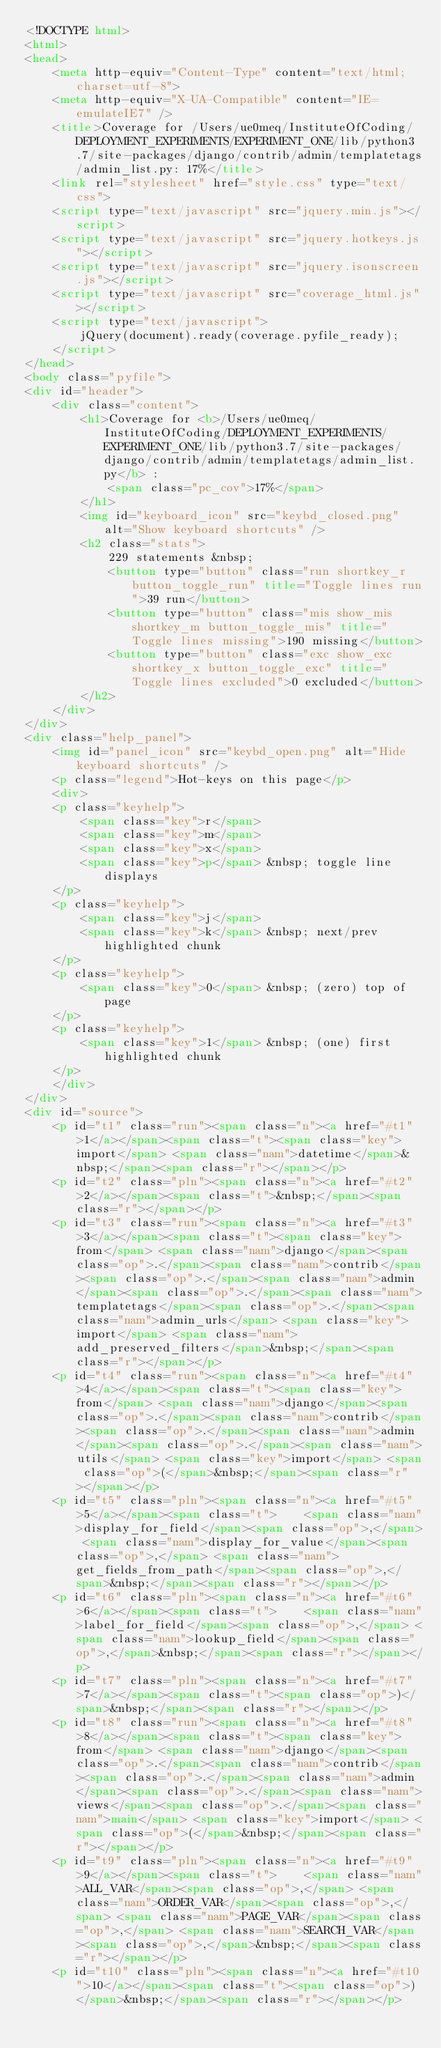Convert code to text. <code><loc_0><loc_0><loc_500><loc_500><_HTML_><!DOCTYPE html>
<html>
<head>
    <meta http-equiv="Content-Type" content="text/html; charset=utf-8">
    <meta http-equiv="X-UA-Compatible" content="IE=emulateIE7" />
    <title>Coverage for /Users/ue0meq/InstituteOfCoding/DEPLOYMENT_EXPERIMENTS/EXPERIMENT_ONE/lib/python3.7/site-packages/django/contrib/admin/templatetags/admin_list.py: 17%</title>
    <link rel="stylesheet" href="style.css" type="text/css">
    <script type="text/javascript" src="jquery.min.js"></script>
    <script type="text/javascript" src="jquery.hotkeys.js"></script>
    <script type="text/javascript" src="jquery.isonscreen.js"></script>
    <script type="text/javascript" src="coverage_html.js"></script>
    <script type="text/javascript">
        jQuery(document).ready(coverage.pyfile_ready);
    </script>
</head>
<body class="pyfile">
<div id="header">
    <div class="content">
        <h1>Coverage for <b>/Users/ue0meq/InstituteOfCoding/DEPLOYMENT_EXPERIMENTS/EXPERIMENT_ONE/lib/python3.7/site-packages/django/contrib/admin/templatetags/admin_list.py</b> :
            <span class="pc_cov">17%</span>
        </h1>
        <img id="keyboard_icon" src="keybd_closed.png" alt="Show keyboard shortcuts" />
        <h2 class="stats">
            229 statements &nbsp;
            <button type="button" class="run shortkey_r button_toggle_run" title="Toggle lines run">39 run</button>
            <button type="button" class="mis show_mis shortkey_m button_toggle_mis" title="Toggle lines missing">190 missing</button>
            <button type="button" class="exc show_exc shortkey_x button_toggle_exc" title="Toggle lines excluded">0 excluded</button>
        </h2>
    </div>
</div>
<div class="help_panel">
    <img id="panel_icon" src="keybd_open.png" alt="Hide keyboard shortcuts" />
    <p class="legend">Hot-keys on this page</p>
    <div>
    <p class="keyhelp">
        <span class="key">r</span>
        <span class="key">m</span>
        <span class="key">x</span>
        <span class="key">p</span> &nbsp; toggle line displays
    </p>
    <p class="keyhelp">
        <span class="key">j</span>
        <span class="key">k</span> &nbsp; next/prev highlighted chunk
    </p>
    <p class="keyhelp">
        <span class="key">0</span> &nbsp; (zero) top of page
    </p>
    <p class="keyhelp">
        <span class="key">1</span> &nbsp; (one) first highlighted chunk
    </p>
    </div>
</div>
<div id="source">
    <p id="t1" class="run"><span class="n"><a href="#t1">1</a></span><span class="t"><span class="key">import</span> <span class="nam">datetime</span>&nbsp;</span><span class="r"></span></p>
    <p id="t2" class="pln"><span class="n"><a href="#t2">2</a></span><span class="t">&nbsp;</span><span class="r"></span></p>
    <p id="t3" class="run"><span class="n"><a href="#t3">3</a></span><span class="t"><span class="key">from</span> <span class="nam">django</span><span class="op">.</span><span class="nam">contrib</span><span class="op">.</span><span class="nam">admin</span><span class="op">.</span><span class="nam">templatetags</span><span class="op">.</span><span class="nam">admin_urls</span> <span class="key">import</span> <span class="nam">add_preserved_filters</span>&nbsp;</span><span class="r"></span></p>
    <p id="t4" class="run"><span class="n"><a href="#t4">4</a></span><span class="t"><span class="key">from</span> <span class="nam">django</span><span class="op">.</span><span class="nam">contrib</span><span class="op">.</span><span class="nam">admin</span><span class="op">.</span><span class="nam">utils</span> <span class="key">import</span> <span class="op">(</span>&nbsp;</span><span class="r"></span></p>
    <p id="t5" class="pln"><span class="n"><a href="#t5">5</a></span><span class="t">    <span class="nam">display_for_field</span><span class="op">,</span> <span class="nam">display_for_value</span><span class="op">,</span> <span class="nam">get_fields_from_path</span><span class="op">,</span>&nbsp;</span><span class="r"></span></p>
    <p id="t6" class="pln"><span class="n"><a href="#t6">6</a></span><span class="t">    <span class="nam">label_for_field</span><span class="op">,</span> <span class="nam">lookup_field</span><span class="op">,</span>&nbsp;</span><span class="r"></span></p>
    <p id="t7" class="pln"><span class="n"><a href="#t7">7</a></span><span class="t"><span class="op">)</span>&nbsp;</span><span class="r"></span></p>
    <p id="t8" class="run"><span class="n"><a href="#t8">8</a></span><span class="t"><span class="key">from</span> <span class="nam">django</span><span class="op">.</span><span class="nam">contrib</span><span class="op">.</span><span class="nam">admin</span><span class="op">.</span><span class="nam">views</span><span class="op">.</span><span class="nam">main</span> <span class="key">import</span> <span class="op">(</span>&nbsp;</span><span class="r"></span></p>
    <p id="t9" class="pln"><span class="n"><a href="#t9">9</a></span><span class="t">    <span class="nam">ALL_VAR</span><span class="op">,</span> <span class="nam">ORDER_VAR</span><span class="op">,</span> <span class="nam">PAGE_VAR</span><span class="op">,</span> <span class="nam">SEARCH_VAR</span><span class="op">,</span>&nbsp;</span><span class="r"></span></p>
    <p id="t10" class="pln"><span class="n"><a href="#t10">10</a></span><span class="t"><span class="op">)</span>&nbsp;</span><span class="r"></span></p></code> 